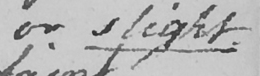Please transcribe the handwritten text in this image. or slight 